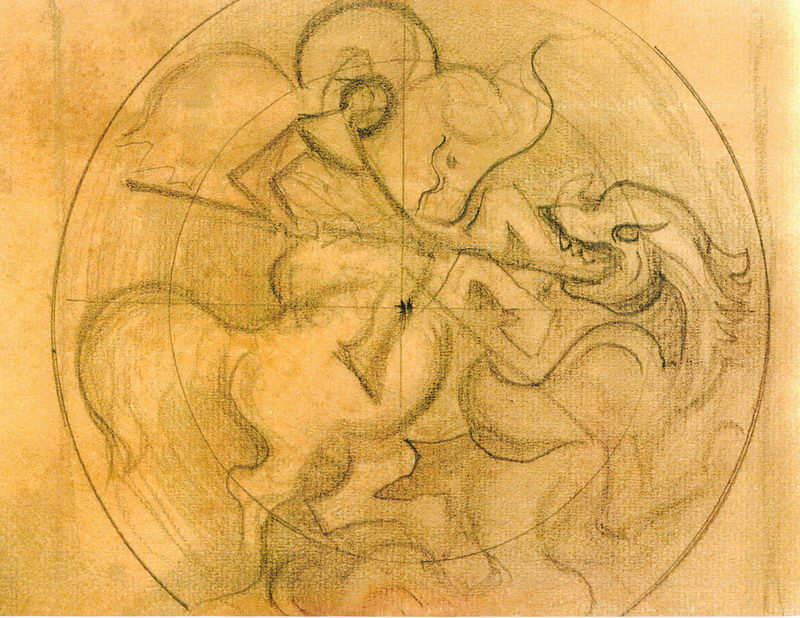Can you discuss the possible symbolic meanings behind the figures' actions in this drawing? Certainly! The figures' intense interaction in this drawing could symbolize various themes such as conflict, struggle, or heroism. These themes are often explored in art to reflect human experiences and emotions. The aggressive postures and expressive gestures might also hint at a deeper narrative, possibly drawing from mythology or historical events where such dramatic expressions of conflict are common. 